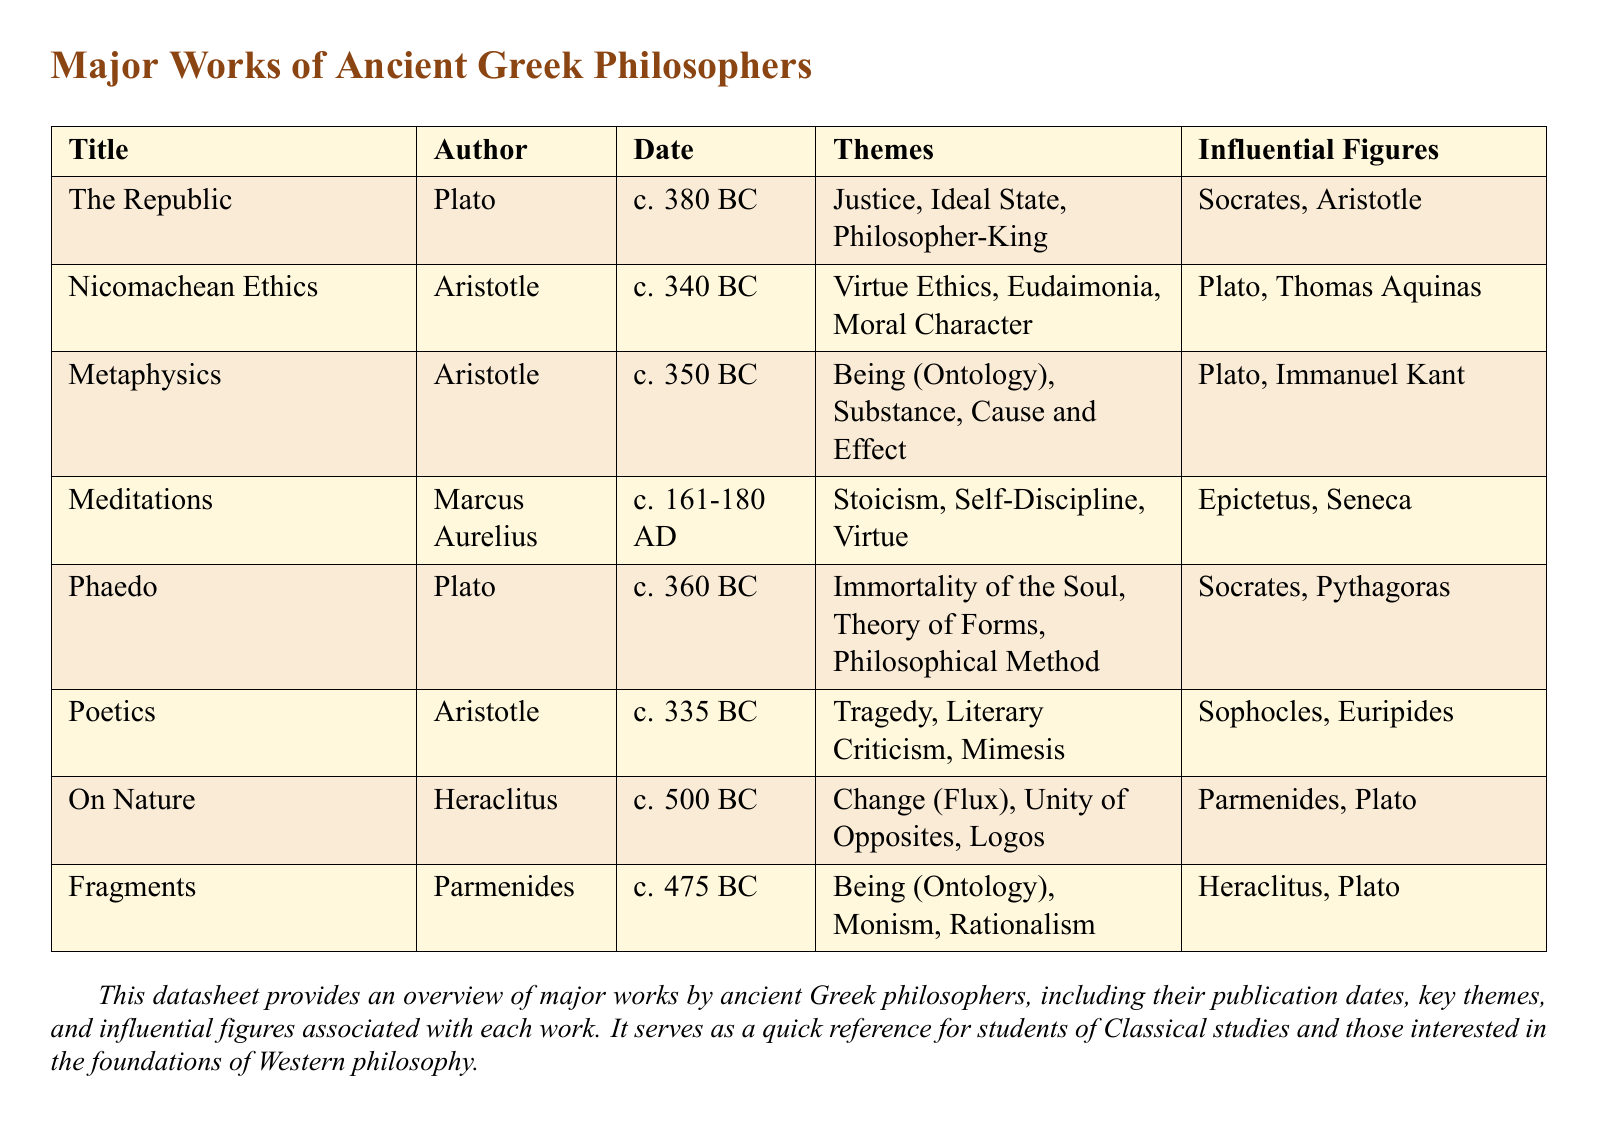What is the title of Plato's work concerning the ideal state? The title of Plato's work that addresses the ideal state is "The Republic."
Answer: The Republic Who authored "Nicomachean Ethics"? The author of "Nicomachean Ethics" is Aristotle.
Answer: Aristotle What is the publication date of "Meditations"? The publication date of "Meditations" is c. 161-180 AD.
Answer: c. 161-180 AD Which theme is associated with Heraclitus's work "On Nature"? The theme associated with "On Nature" by Heraclitus is Change (Flux).
Answer: Change (Flux) Name one influential figure linked to Aristotle. One influential figure linked to Aristotle is Plato.
Answer: Plato What philosophical theme is explored in Parmenides's "Fragments"? The philosophical theme explored in "Fragments" is Being (Ontology).
Answer: Being (Ontology) How many works are listed by Plato in the document? The document lists two works by Plato.
Answer: Two Which philosopher is noted for contributing to Stoicism in "Meditations"? Marcus Aurelius's "Meditations" is noted for contributions to Stoicism.
Answer: Stoicism What is the common theme between "Poetics" and "Nicomachean Ethics"? Both works focus on themes of virtue and ethics, though in different contexts.
Answer: Virtue 